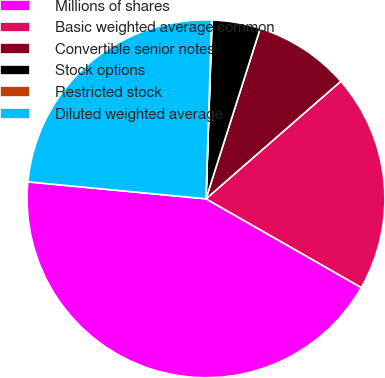Convert chart. <chart><loc_0><loc_0><loc_500><loc_500><pie_chart><fcel>Millions of shares<fcel>Basic weighted average common<fcel>Convertible senior notes<fcel>Stock options<fcel>Restricted stock<fcel>Diluted weighted average<nl><fcel>43.24%<fcel>19.67%<fcel>8.68%<fcel>4.36%<fcel>0.04%<fcel>23.99%<nl></chart> 